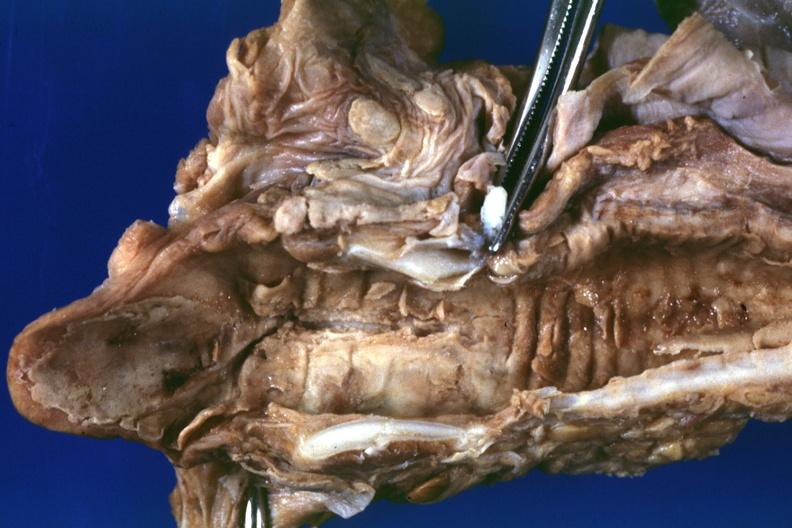s larynx present?
Answer the question using a single word or phrase. Yes 